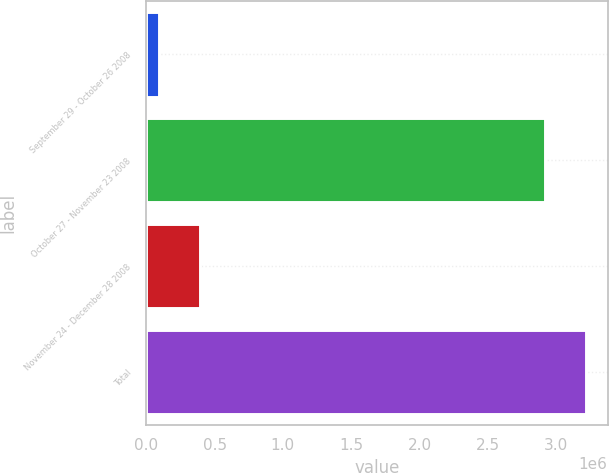<chart> <loc_0><loc_0><loc_500><loc_500><bar_chart><fcel>September 29 - October 26 2008<fcel>October 27 - November 23 2008<fcel>November 24 - December 28 2008<fcel>Total<nl><fcel>92969<fcel>2.91551e+06<fcel>394560<fcel>3.21711e+06<nl></chart> 